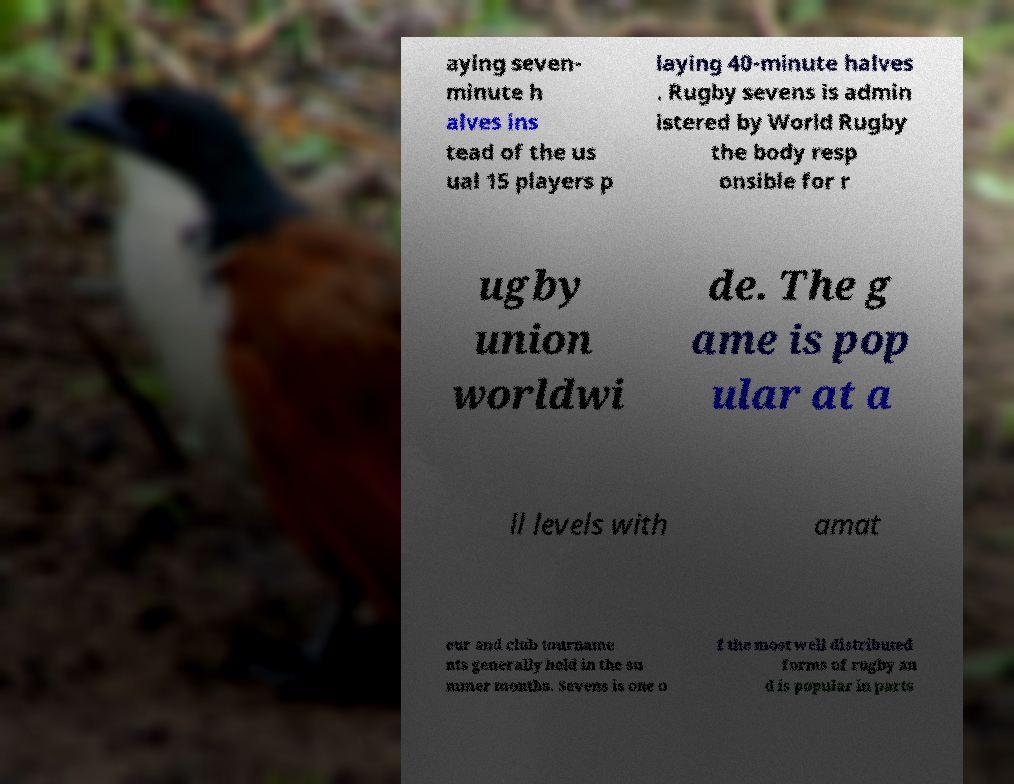Could you extract and type out the text from this image? aying seven- minute h alves ins tead of the us ual 15 players p laying 40-minute halves . Rugby sevens is admin istered by World Rugby the body resp onsible for r ugby union worldwi de. The g ame is pop ular at a ll levels with amat eur and club tourname nts generally held in the su mmer months. Sevens is one o f the most well distributed forms of rugby an d is popular in parts 